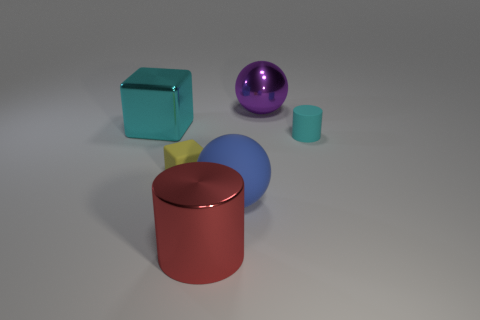Add 2 blue matte objects. How many objects exist? 8 Subtract all spheres. How many objects are left? 4 Add 3 yellow metal cylinders. How many yellow metal cylinders exist? 3 Subtract 0 brown blocks. How many objects are left? 6 Subtract all small gray matte cylinders. Subtract all big metal things. How many objects are left? 3 Add 1 big red objects. How many big red objects are left? 2 